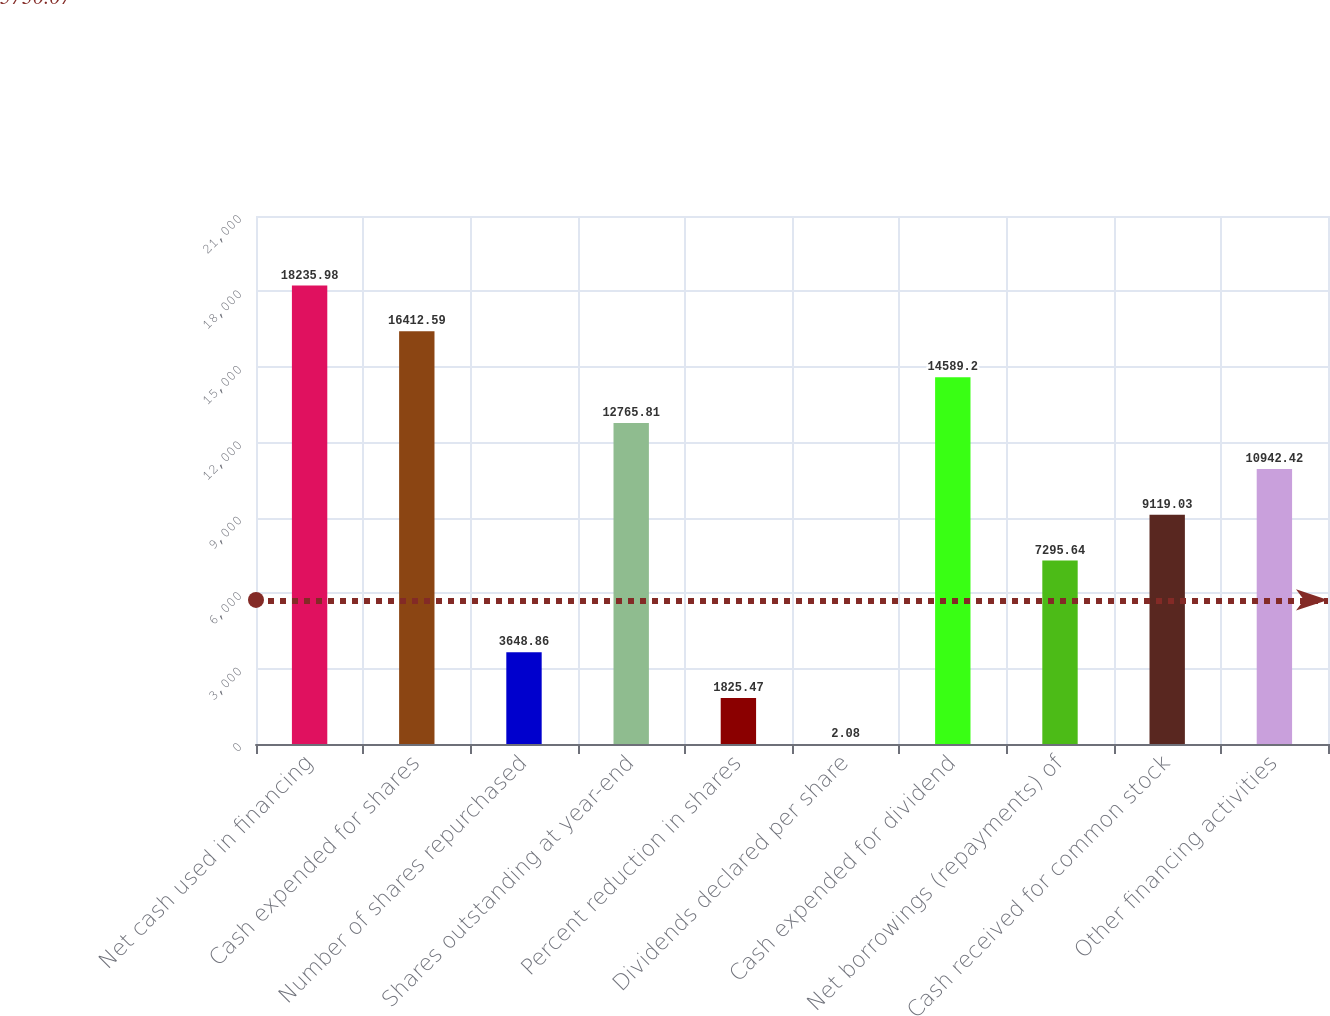<chart> <loc_0><loc_0><loc_500><loc_500><bar_chart><fcel>Net cash used in financing<fcel>Cash expended for shares<fcel>Number of shares repurchased<fcel>Shares outstanding at year-end<fcel>Percent reduction in shares<fcel>Dividends declared per share<fcel>Cash expended for dividend<fcel>Net borrowings (repayments) of<fcel>Cash received for common stock<fcel>Other financing activities<nl><fcel>18236<fcel>16412.6<fcel>3648.86<fcel>12765.8<fcel>1825.47<fcel>2.08<fcel>14589.2<fcel>7295.64<fcel>9119.03<fcel>10942.4<nl></chart> 